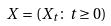Convert formula to latex. <formula><loc_0><loc_0><loc_500><loc_500>X = ( X _ { t } \colon t \geq 0 )</formula> 